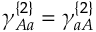<formula> <loc_0><loc_0><loc_500><loc_500>\gamma _ { A a } ^ { \{ 2 \} } = \gamma _ { a A } ^ { \{ 2 \} }</formula> 